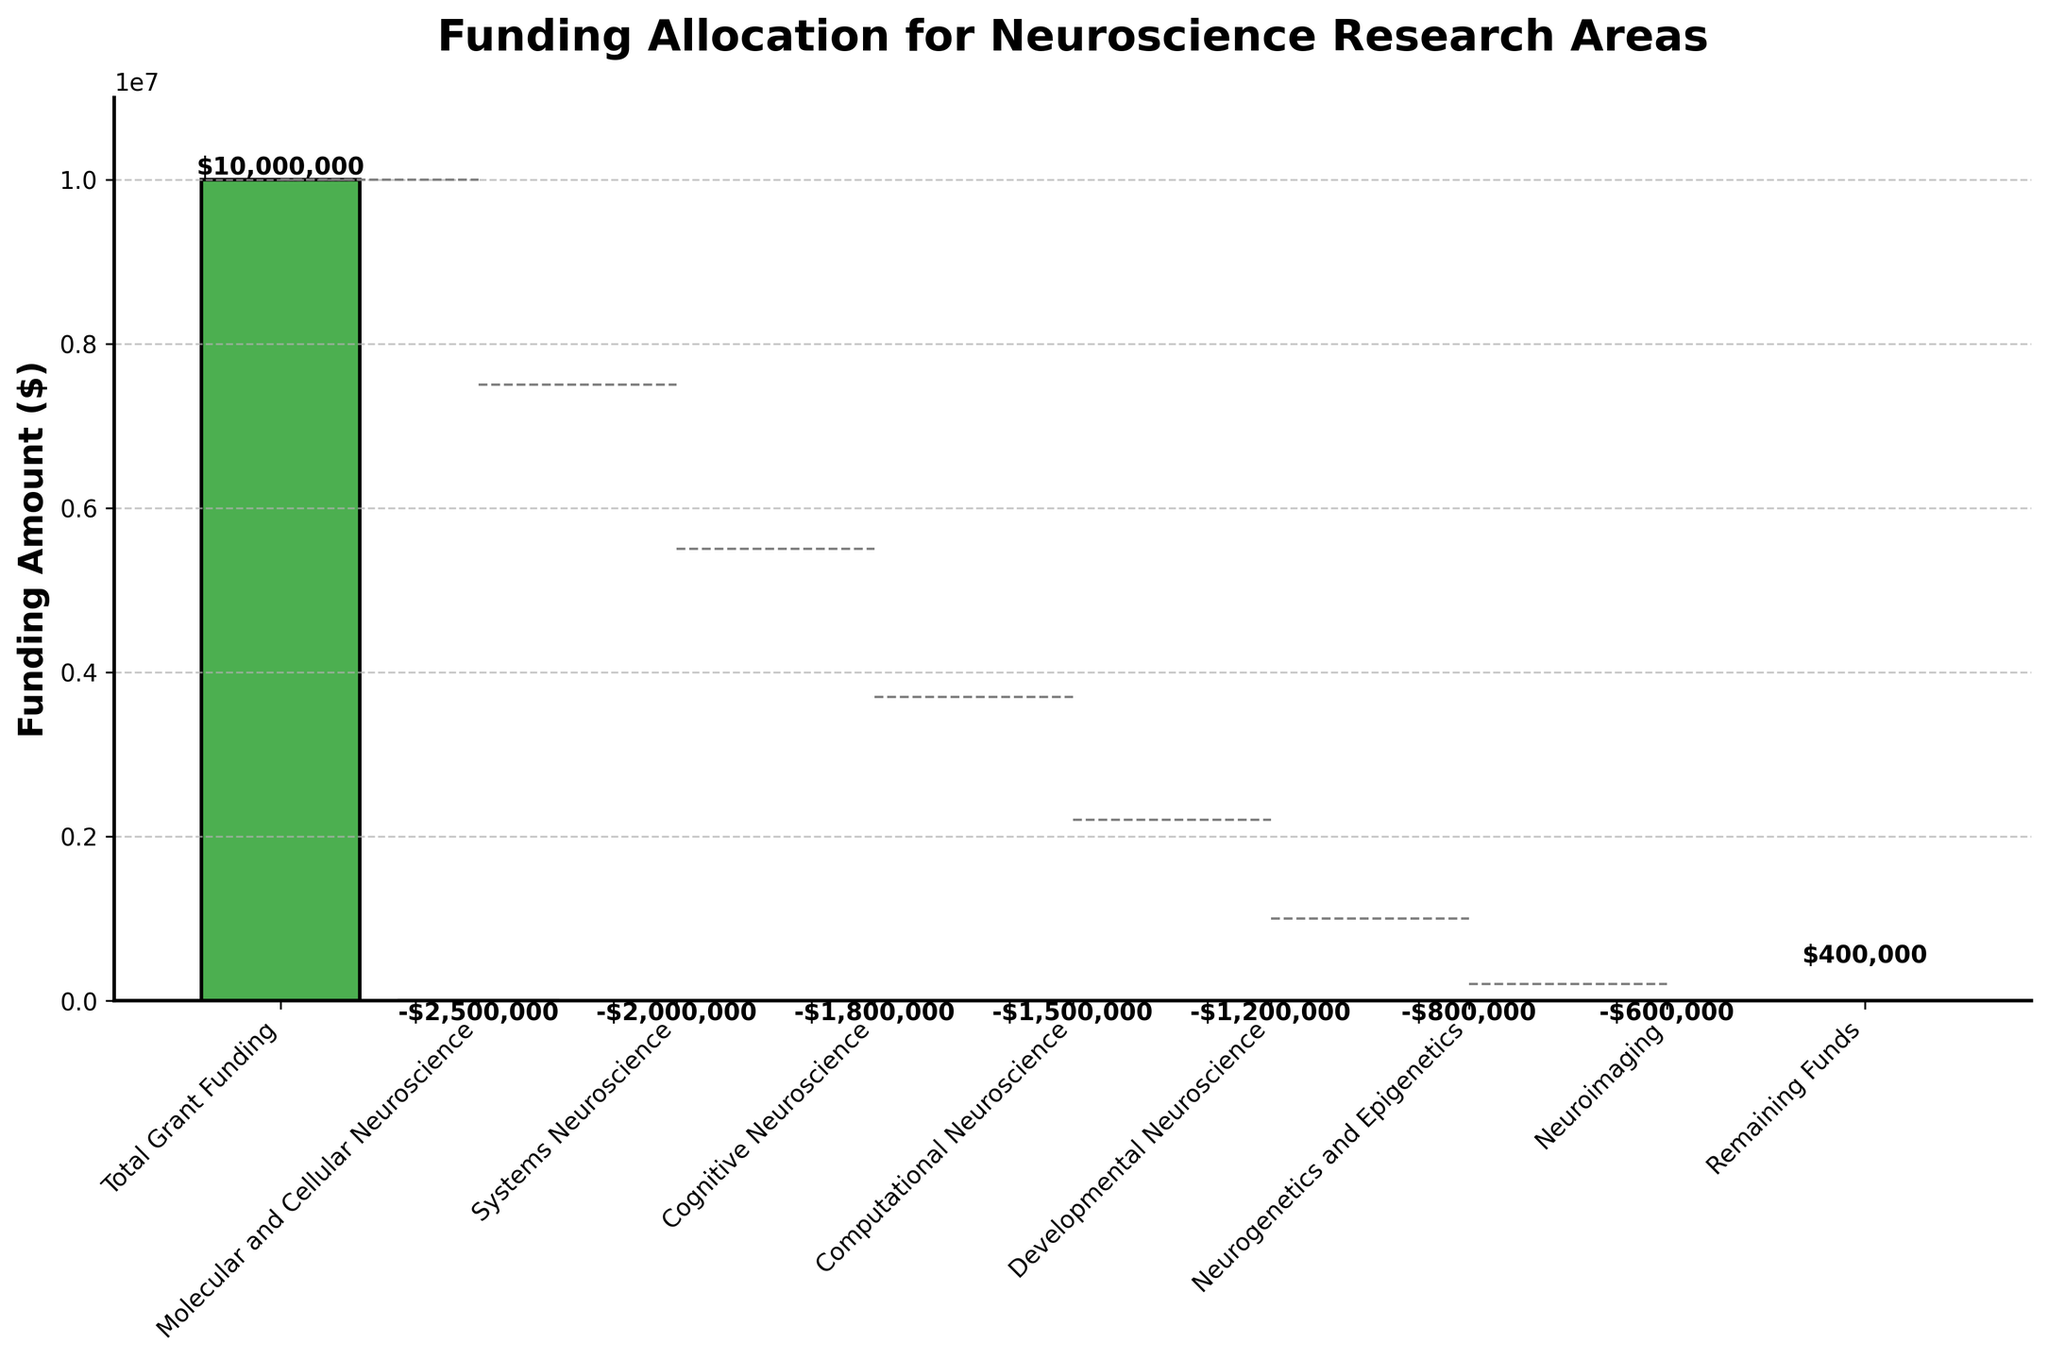What is the total amount of grant funding available? The total amount of grant funding is displayed at the top of the waterfall chart. It is labeled as "Total Grant Funding."
Answer: $10,000,000 What is the amount allocated to Molecular and Cellular Neuroscience? In the waterfall chart, the "Molecular and Cellular Neuroscience" category shows the downward bar with the allocated amount.
Answer: $2,500,000 How much funding is allocated to Neurogenetics and Epigenetics? The bar representing "Neurogenetics and Epigenetics" on the waterfall chart indicates the amount allocated to this category.
Answer: $800,000 Which category received the least amount of funding? The shortest bar in terms of funding decrease after the total funding bar represents the category with the least funding.
Answer: Neuroimaging How much remaining funds are left after all allocations? The final category labeled "Remaining Funds" shows the elevation indicating the remaining amount after all the deductions.
Answer: $400,000 Which category received more funding, Systems Neuroscience or Cognitive Neuroscience? Comparing the heights of the bars labeled "Systems Neuroscience" and "Cognitive Neuroscience" shows which received more funding. "Systems Neuroscience" has a taller bar representing a greater reduction in funding.
Answer: Systems Neuroscience What is the total amount allocated to Cognitive Neuroscience and Developmental Neuroscience combined? Calculate by adding the amounts of both categories: $1,800,000 (Cognitive Neuroscience) + $1,200,000 (Developmental Neuroscience) = $3,000,000
Answer: $3,000,000 Which is the second-highest funded category? After the total funding, the second tallest downward bar represents "Molecular and Cellular Neuroscience," indicating it as the second highest funded category.
Answer: Molecular and Cellular Neuroscience How does the funding for Computational Neuroscience compare to Neuroimaging? By comparing the lengths of the blue bar (Computational Neuroscience) and the orange bar (Neuroimaging), one can see that "Computational Neuroscience" has a taller bar, indicating a larger allocation.
Answer: Computational Neuroscience What is the sum of funding allocated to Molecular and Cellular Neuroscience, and Neurogenetics and Epigenetics? Add the funding for both categories: $2,500,000 (Molecular and Cellular Neuroscience) + $800,000 (Neurogenetics and Epigenetics) = $3,300,000
Answer: $3,300,000 